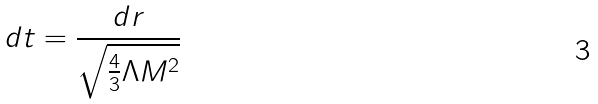<formula> <loc_0><loc_0><loc_500><loc_500>d t = \frac { d r } { \sqrt { \frac { 4 } { 3 } \Lambda M ^ { 2 } } }</formula> 